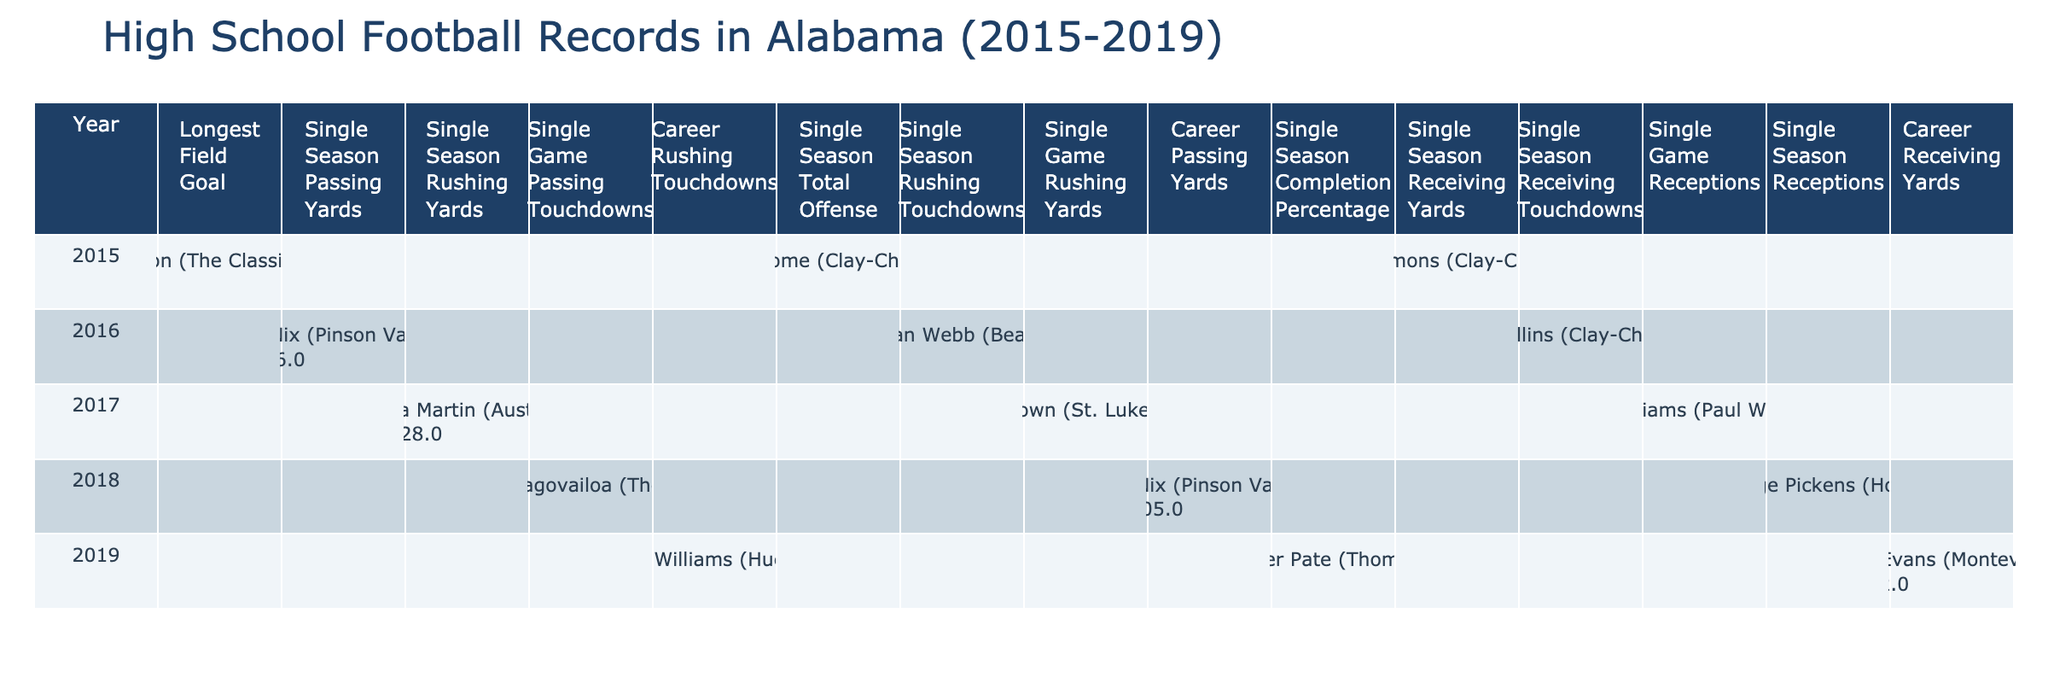What was the longest field goal made in Alabama high school football during the years 2015-2019? In the table, under the "Longest Field Goal" record type for the year 2015, Anders Carlson made a field goal of 54 yards.
Answer: 54 yards Who had the highest single season passing yards in Alabama high school football during this period? The table shows that Bo Nix had the highest single season passing yards with 3,496 yards in 2016.
Answer: 3,496 yards How many single season rushing touchdowns did La'Damian Webb achieve in 2016? Referring to the record type "Single Season Rushing Touchdowns" for the year 2016, La'Damian Webb achieved 47 rushing touchdowns.
Answer: 47 Which player recorded the most career rushing touchdowns by 2019? The table shows that Roydell Williams had the most career rushing touchdowns, totaling 92 by 2019.
Answer: 92 Which year did Asa Martin achieve the highest single season rushing yards? According to the table, Asa Martin achieved the highest single season rushing yards in 2017 with 2,228 yards.
Answer: 2017 What is the total number of single season records listed for all players in 2015? The single season records listed for 2015 in the table include Longest Field Goal, Single Season Total Offense, and Single Season Receiving Yards, which total to 3 records.
Answer: 3 records Is there a player who scored more than 400 passing touchdowns? Upon reviewing the data, there are no players listed with passing touchdowns in the data presented, thus the answer is no.
Answer: No Which player had the most receptions in a single game, and in what year? The table indicates that Seth Williams had the most receptions in a single game with 18, recorded in 2017.
Answer: 18 receptions in 2017 What is the difference in single season rushing yards between Asa Martin and La'Damian Webb? Asa Martin had 2,228 rushing yards in 2017, while La'Damian Webb had rushing touchdowns, not yards, so we cannot compute a difference in rushing yards. In terms of rushing touchdowns vs. rushing yards, the specific data comparison cannot be made.
Answer: Not computable Which school did George Pickens represent and what was his record type in 2018? In 2018, George Pickens represented Hoover and achieved the record for Single Season Receptions with 69.
Answer: Hoover, 69 Receptions 